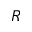<formula> <loc_0><loc_0><loc_500><loc_500>R</formula> 